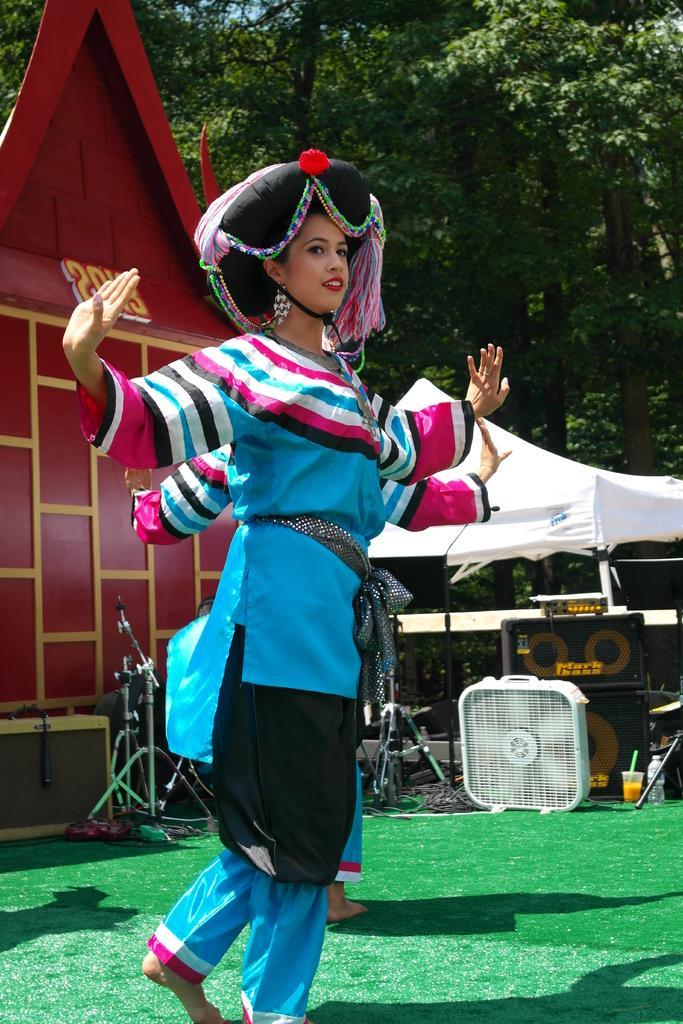Please provide a concise description of this image. In the image we can see there is a woman standing and she is wearing hat. There is another person standing on the ground and the ground is covered with grass. Behind there is mic stand, speaker boxes, fan and tent. There is a building and there are trees at the back. 